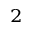Convert formula to latex. <formula><loc_0><loc_0><loc_500><loc_500>^ { 2 }</formula> 